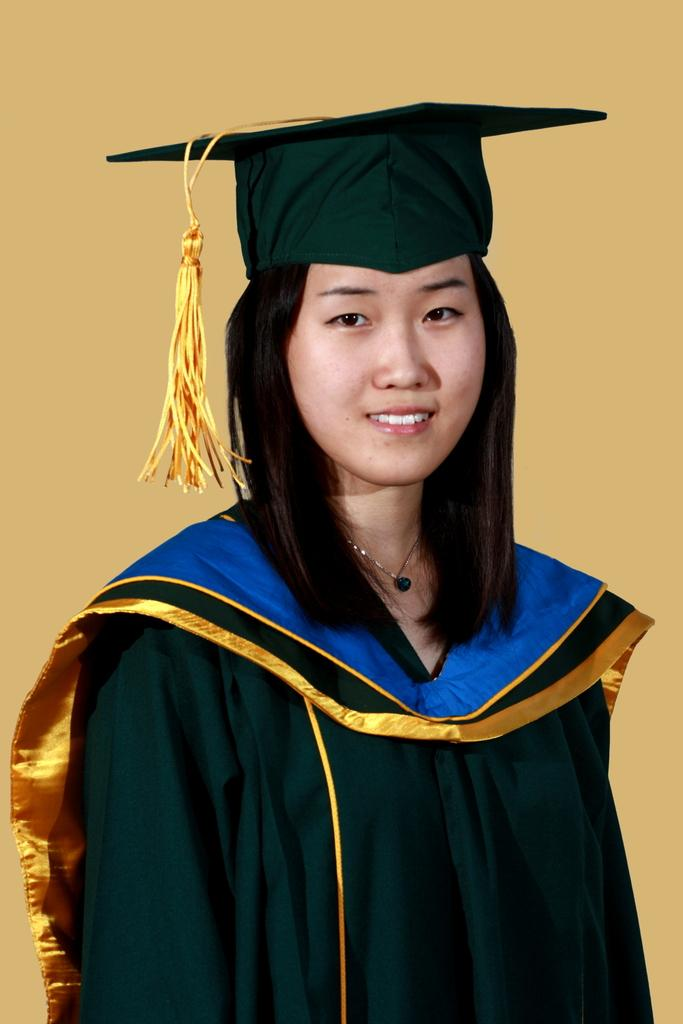Who is the main subject in the image? There is a woman in the image. Can you describe the woman's appearance? The woman is beautiful. What is the woman doing in the image? The woman is standing. What is the woman wearing in the image? The woman is wearing a black coat and a cap. What type of soup is the woman holding in the image? There is no soup present in the image; the woman is wearing a black coat and a cap. Can you tell me where the goat is located in the image? There is no goat present in the image. 